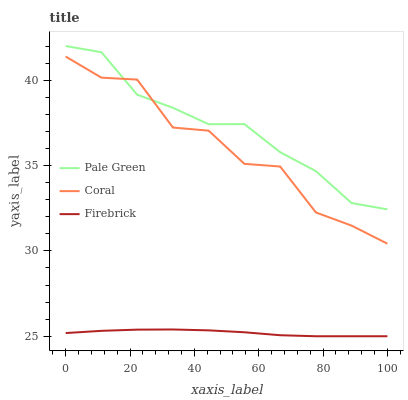Does Firebrick have the minimum area under the curve?
Answer yes or no. Yes. Does Pale Green have the maximum area under the curve?
Answer yes or no. Yes. Does Pale Green have the minimum area under the curve?
Answer yes or no. No. Does Firebrick have the maximum area under the curve?
Answer yes or no. No. Is Firebrick the smoothest?
Answer yes or no. Yes. Is Coral the roughest?
Answer yes or no. Yes. Is Pale Green the smoothest?
Answer yes or no. No. Is Pale Green the roughest?
Answer yes or no. No. Does Firebrick have the lowest value?
Answer yes or no. Yes. Does Pale Green have the lowest value?
Answer yes or no. No. Does Pale Green have the highest value?
Answer yes or no. Yes. Does Firebrick have the highest value?
Answer yes or no. No. Is Firebrick less than Coral?
Answer yes or no. Yes. Is Pale Green greater than Firebrick?
Answer yes or no. Yes. Does Pale Green intersect Coral?
Answer yes or no. Yes. Is Pale Green less than Coral?
Answer yes or no. No. Is Pale Green greater than Coral?
Answer yes or no. No. Does Firebrick intersect Coral?
Answer yes or no. No. 